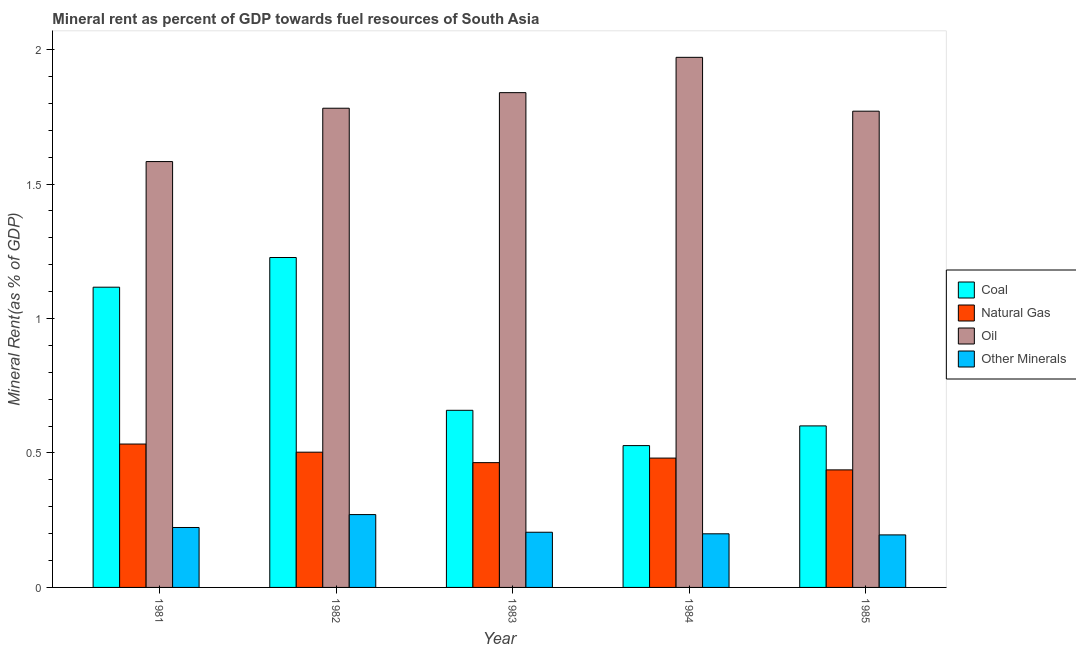How many groups of bars are there?
Provide a succinct answer. 5. Are the number of bars per tick equal to the number of legend labels?
Offer a terse response. Yes. How many bars are there on the 5th tick from the right?
Offer a very short reply. 4. In how many cases, is the number of bars for a given year not equal to the number of legend labels?
Make the answer very short. 0. What is the coal rent in 1984?
Provide a short and direct response. 0.53. Across all years, what is the maximum oil rent?
Keep it short and to the point. 1.97. Across all years, what is the minimum natural gas rent?
Provide a short and direct response. 0.44. In which year was the coal rent maximum?
Offer a terse response. 1982. In which year was the coal rent minimum?
Ensure brevity in your answer.  1984. What is the total  rent of other minerals in the graph?
Provide a succinct answer. 1.09. What is the difference between the natural gas rent in 1982 and that in 1983?
Offer a very short reply. 0.04. What is the difference between the  rent of other minerals in 1985 and the oil rent in 1983?
Keep it short and to the point. -0.01. What is the average coal rent per year?
Your answer should be very brief. 0.83. In the year 1985, what is the difference between the natural gas rent and  rent of other minerals?
Provide a succinct answer. 0. What is the ratio of the oil rent in 1983 to that in 1984?
Offer a terse response. 0.93. Is the natural gas rent in 1982 less than that in 1984?
Give a very brief answer. No. What is the difference between the highest and the second highest oil rent?
Ensure brevity in your answer.  0.13. What is the difference between the highest and the lowest coal rent?
Offer a very short reply. 0.7. Is the sum of the natural gas rent in 1983 and 1984 greater than the maximum coal rent across all years?
Make the answer very short. Yes. What does the 3rd bar from the left in 1982 represents?
Keep it short and to the point. Oil. What does the 2nd bar from the right in 1981 represents?
Make the answer very short. Oil. Is it the case that in every year, the sum of the coal rent and natural gas rent is greater than the oil rent?
Keep it short and to the point. No. What is the difference between two consecutive major ticks on the Y-axis?
Your answer should be very brief. 0.5. Are the values on the major ticks of Y-axis written in scientific E-notation?
Give a very brief answer. No. Does the graph contain grids?
Offer a very short reply. No. How are the legend labels stacked?
Provide a short and direct response. Vertical. What is the title of the graph?
Ensure brevity in your answer.  Mineral rent as percent of GDP towards fuel resources of South Asia. Does "Secondary" appear as one of the legend labels in the graph?
Your answer should be compact. No. What is the label or title of the Y-axis?
Your answer should be compact. Mineral Rent(as % of GDP). What is the Mineral Rent(as % of GDP) of Coal in 1981?
Offer a very short reply. 1.12. What is the Mineral Rent(as % of GDP) of Natural Gas in 1981?
Give a very brief answer. 0.53. What is the Mineral Rent(as % of GDP) of Oil in 1981?
Offer a very short reply. 1.58. What is the Mineral Rent(as % of GDP) in Other Minerals in 1981?
Your answer should be very brief. 0.22. What is the Mineral Rent(as % of GDP) in Coal in 1982?
Provide a succinct answer. 1.23. What is the Mineral Rent(as % of GDP) in Natural Gas in 1982?
Make the answer very short. 0.5. What is the Mineral Rent(as % of GDP) in Oil in 1982?
Offer a very short reply. 1.78. What is the Mineral Rent(as % of GDP) in Other Minerals in 1982?
Make the answer very short. 0.27. What is the Mineral Rent(as % of GDP) in Coal in 1983?
Ensure brevity in your answer.  0.66. What is the Mineral Rent(as % of GDP) in Natural Gas in 1983?
Your answer should be very brief. 0.46. What is the Mineral Rent(as % of GDP) in Oil in 1983?
Your answer should be compact. 1.84. What is the Mineral Rent(as % of GDP) of Other Minerals in 1983?
Keep it short and to the point. 0.21. What is the Mineral Rent(as % of GDP) in Coal in 1984?
Your answer should be very brief. 0.53. What is the Mineral Rent(as % of GDP) of Natural Gas in 1984?
Offer a very short reply. 0.48. What is the Mineral Rent(as % of GDP) in Oil in 1984?
Provide a short and direct response. 1.97. What is the Mineral Rent(as % of GDP) in Other Minerals in 1984?
Provide a succinct answer. 0.2. What is the Mineral Rent(as % of GDP) of Coal in 1985?
Your answer should be very brief. 0.6. What is the Mineral Rent(as % of GDP) of Natural Gas in 1985?
Your response must be concise. 0.44. What is the Mineral Rent(as % of GDP) of Oil in 1985?
Provide a short and direct response. 1.77. What is the Mineral Rent(as % of GDP) in Other Minerals in 1985?
Your answer should be very brief. 0.2. Across all years, what is the maximum Mineral Rent(as % of GDP) in Coal?
Ensure brevity in your answer.  1.23. Across all years, what is the maximum Mineral Rent(as % of GDP) of Natural Gas?
Provide a succinct answer. 0.53. Across all years, what is the maximum Mineral Rent(as % of GDP) in Oil?
Keep it short and to the point. 1.97. Across all years, what is the maximum Mineral Rent(as % of GDP) of Other Minerals?
Provide a short and direct response. 0.27. Across all years, what is the minimum Mineral Rent(as % of GDP) in Coal?
Ensure brevity in your answer.  0.53. Across all years, what is the minimum Mineral Rent(as % of GDP) in Natural Gas?
Give a very brief answer. 0.44. Across all years, what is the minimum Mineral Rent(as % of GDP) in Oil?
Your answer should be very brief. 1.58. Across all years, what is the minimum Mineral Rent(as % of GDP) in Other Minerals?
Make the answer very short. 0.2. What is the total Mineral Rent(as % of GDP) in Coal in the graph?
Your answer should be very brief. 4.13. What is the total Mineral Rent(as % of GDP) in Natural Gas in the graph?
Make the answer very short. 2.42. What is the total Mineral Rent(as % of GDP) of Oil in the graph?
Provide a short and direct response. 8.95. What is the total Mineral Rent(as % of GDP) in Other Minerals in the graph?
Give a very brief answer. 1.09. What is the difference between the Mineral Rent(as % of GDP) of Coal in 1981 and that in 1982?
Offer a terse response. -0.11. What is the difference between the Mineral Rent(as % of GDP) in Natural Gas in 1981 and that in 1982?
Give a very brief answer. 0.03. What is the difference between the Mineral Rent(as % of GDP) of Oil in 1981 and that in 1982?
Provide a succinct answer. -0.2. What is the difference between the Mineral Rent(as % of GDP) in Other Minerals in 1981 and that in 1982?
Offer a very short reply. -0.05. What is the difference between the Mineral Rent(as % of GDP) of Coal in 1981 and that in 1983?
Offer a very short reply. 0.46. What is the difference between the Mineral Rent(as % of GDP) of Natural Gas in 1981 and that in 1983?
Keep it short and to the point. 0.07. What is the difference between the Mineral Rent(as % of GDP) in Oil in 1981 and that in 1983?
Ensure brevity in your answer.  -0.26. What is the difference between the Mineral Rent(as % of GDP) in Other Minerals in 1981 and that in 1983?
Your answer should be very brief. 0.02. What is the difference between the Mineral Rent(as % of GDP) in Coal in 1981 and that in 1984?
Make the answer very short. 0.59. What is the difference between the Mineral Rent(as % of GDP) in Natural Gas in 1981 and that in 1984?
Offer a terse response. 0.05. What is the difference between the Mineral Rent(as % of GDP) of Oil in 1981 and that in 1984?
Provide a short and direct response. -0.39. What is the difference between the Mineral Rent(as % of GDP) of Other Minerals in 1981 and that in 1984?
Make the answer very short. 0.02. What is the difference between the Mineral Rent(as % of GDP) of Coal in 1981 and that in 1985?
Ensure brevity in your answer.  0.52. What is the difference between the Mineral Rent(as % of GDP) in Natural Gas in 1981 and that in 1985?
Offer a terse response. 0.1. What is the difference between the Mineral Rent(as % of GDP) of Oil in 1981 and that in 1985?
Give a very brief answer. -0.19. What is the difference between the Mineral Rent(as % of GDP) of Other Minerals in 1981 and that in 1985?
Offer a very short reply. 0.03. What is the difference between the Mineral Rent(as % of GDP) in Coal in 1982 and that in 1983?
Offer a terse response. 0.57. What is the difference between the Mineral Rent(as % of GDP) of Natural Gas in 1982 and that in 1983?
Offer a very short reply. 0.04. What is the difference between the Mineral Rent(as % of GDP) of Oil in 1982 and that in 1983?
Offer a terse response. -0.06. What is the difference between the Mineral Rent(as % of GDP) of Other Minerals in 1982 and that in 1983?
Make the answer very short. 0.07. What is the difference between the Mineral Rent(as % of GDP) in Coal in 1982 and that in 1984?
Your answer should be very brief. 0.7. What is the difference between the Mineral Rent(as % of GDP) in Natural Gas in 1982 and that in 1984?
Your answer should be compact. 0.02. What is the difference between the Mineral Rent(as % of GDP) of Oil in 1982 and that in 1984?
Provide a short and direct response. -0.19. What is the difference between the Mineral Rent(as % of GDP) in Other Minerals in 1982 and that in 1984?
Your answer should be very brief. 0.07. What is the difference between the Mineral Rent(as % of GDP) in Coal in 1982 and that in 1985?
Provide a short and direct response. 0.63. What is the difference between the Mineral Rent(as % of GDP) in Natural Gas in 1982 and that in 1985?
Keep it short and to the point. 0.07. What is the difference between the Mineral Rent(as % of GDP) in Oil in 1982 and that in 1985?
Offer a very short reply. 0.01. What is the difference between the Mineral Rent(as % of GDP) in Other Minerals in 1982 and that in 1985?
Your response must be concise. 0.08. What is the difference between the Mineral Rent(as % of GDP) of Coal in 1983 and that in 1984?
Make the answer very short. 0.13. What is the difference between the Mineral Rent(as % of GDP) of Natural Gas in 1983 and that in 1984?
Offer a terse response. -0.02. What is the difference between the Mineral Rent(as % of GDP) in Oil in 1983 and that in 1984?
Provide a succinct answer. -0.13. What is the difference between the Mineral Rent(as % of GDP) in Other Minerals in 1983 and that in 1984?
Provide a succinct answer. 0.01. What is the difference between the Mineral Rent(as % of GDP) in Coal in 1983 and that in 1985?
Provide a short and direct response. 0.06. What is the difference between the Mineral Rent(as % of GDP) of Natural Gas in 1983 and that in 1985?
Make the answer very short. 0.03. What is the difference between the Mineral Rent(as % of GDP) in Oil in 1983 and that in 1985?
Keep it short and to the point. 0.07. What is the difference between the Mineral Rent(as % of GDP) of Other Minerals in 1983 and that in 1985?
Offer a terse response. 0.01. What is the difference between the Mineral Rent(as % of GDP) of Coal in 1984 and that in 1985?
Provide a succinct answer. -0.07. What is the difference between the Mineral Rent(as % of GDP) in Natural Gas in 1984 and that in 1985?
Offer a very short reply. 0.04. What is the difference between the Mineral Rent(as % of GDP) of Oil in 1984 and that in 1985?
Your answer should be very brief. 0.2. What is the difference between the Mineral Rent(as % of GDP) of Other Minerals in 1984 and that in 1985?
Your answer should be very brief. 0. What is the difference between the Mineral Rent(as % of GDP) of Coal in 1981 and the Mineral Rent(as % of GDP) of Natural Gas in 1982?
Your response must be concise. 0.61. What is the difference between the Mineral Rent(as % of GDP) in Coal in 1981 and the Mineral Rent(as % of GDP) in Oil in 1982?
Give a very brief answer. -0.67. What is the difference between the Mineral Rent(as % of GDP) of Coal in 1981 and the Mineral Rent(as % of GDP) of Other Minerals in 1982?
Provide a short and direct response. 0.85. What is the difference between the Mineral Rent(as % of GDP) of Natural Gas in 1981 and the Mineral Rent(as % of GDP) of Oil in 1982?
Your answer should be compact. -1.25. What is the difference between the Mineral Rent(as % of GDP) in Natural Gas in 1981 and the Mineral Rent(as % of GDP) in Other Minerals in 1982?
Ensure brevity in your answer.  0.26. What is the difference between the Mineral Rent(as % of GDP) in Oil in 1981 and the Mineral Rent(as % of GDP) in Other Minerals in 1982?
Provide a short and direct response. 1.31. What is the difference between the Mineral Rent(as % of GDP) of Coal in 1981 and the Mineral Rent(as % of GDP) of Natural Gas in 1983?
Give a very brief answer. 0.65. What is the difference between the Mineral Rent(as % of GDP) in Coal in 1981 and the Mineral Rent(as % of GDP) in Oil in 1983?
Make the answer very short. -0.72. What is the difference between the Mineral Rent(as % of GDP) in Coal in 1981 and the Mineral Rent(as % of GDP) in Other Minerals in 1983?
Provide a short and direct response. 0.91. What is the difference between the Mineral Rent(as % of GDP) of Natural Gas in 1981 and the Mineral Rent(as % of GDP) of Oil in 1983?
Ensure brevity in your answer.  -1.31. What is the difference between the Mineral Rent(as % of GDP) in Natural Gas in 1981 and the Mineral Rent(as % of GDP) in Other Minerals in 1983?
Your response must be concise. 0.33. What is the difference between the Mineral Rent(as % of GDP) in Oil in 1981 and the Mineral Rent(as % of GDP) in Other Minerals in 1983?
Ensure brevity in your answer.  1.38. What is the difference between the Mineral Rent(as % of GDP) of Coal in 1981 and the Mineral Rent(as % of GDP) of Natural Gas in 1984?
Your answer should be very brief. 0.64. What is the difference between the Mineral Rent(as % of GDP) in Coal in 1981 and the Mineral Rent(as % of GDP) in Oil in 1984?
Give a very brief answer. -0.85. What is the difference between the Mineral Rent(as % of GDP) in Coal in 1981 and the Mineral Rent(as % of GDP) in Other Minerals in 1984?
Offer a very short reply. 0.92. What is the difference between the Mineral Rent(as % of GDP) in Natural Gas in 1981 and the Mineral Rent(as % of GDP) in Oil in 1984?
Your answer should be very brief. -1.44. What is the difference between the Mineral Rent(as % of GDP) in Natural Gas in 1981 and the Mineral Rent(as % of GDP) in Other Minerals in 1984?
Make the answer very short. 0.33. What is the difference between the Mineral Rent(as % of GDP) in Oil in 1981 and the Mineral Rent(as % of GDP) in Other Minerals in 1984?
Ensure brevity in your answer.  1.38. What is the difference between the Mineral Rent(as % of GDP) of Coal in 1981 and the Mineral Rent(as % of GDP) of Natural Gas in 1985?
Offer a very short reply. 0.68. What is the difference between the Mineral Rent(as % of GDP) of Coal in 1981 and the Mineral Rent(as % of GDP) of Oil in 1985?
Your answer should be compact. -0.65. What is the difference between the Mineral Rent(as % of GDP) of Coal in 1981 and the Mineral Rent(as % of GDP) of Other Minerals in 1985?
Make the answer very short. 0.92. What is the difference between the Mineral Rent(as % of GDP) in Natural Gas in 1981 and the Mineral Rent(as % of GDP) in Oil in 1985?
Keep it short and to the point. -1.24. What is the difference between the Mineral Rent(as % of GDP) in Natural Gas in 1981 and the Mineral Rent(as % of GDP) in Other Minerals in 1985?
Provide a short and direct response. 0.34. What is the difference between the Mineral Rent(as % of GDP) of Oil in 1981 and the Mineral Rent(as % of GDP) of Other Minerals in 1985?
Make the answer very short. 1.39. What is the difference between the Mineral Rent(as % of GDP) in Coal in 1982 and the Mineral Rent(as % of GDP) in Natural Gas in 1983?
Offer a very short reply. 0.76. What is the difference between the Mineral Rent(as % of GDP) of Coal in 1982 and the Mineral Rent(as % of GDP) of Oil in 1983?
Provide a short and direct response. -0.61. What is the difference between the Mineral Rent(as % of GDP) of Coal in 1982 and the Mineral Rent(as % of GDP) of Other Minerals in 1983?
Offer a terse response. 1.02. What is the difference between the Mineral Rent(as % of GDP) of Natural Gas in 1982 and the Mineral Rent(as % of GDP) of Oil in 1983?
Keep it short and to the point. -1.34. What is the difference between the Mineral Rent(as % of GDP) in Natural Gas in 1982 and the Mineral Rent(as % of GDP) in Other Minerals in 1983?
Provide a short and direct response. 0.3. What is the difference between the Mineral Rent(as % of GDP) of Oil in 1982 and the Mineral Rent(as % of GDP) of Other Minerals in 1983?
Give a very brief answer. 1.58. What is the difference between the Mineral Rent(as % of GDP) in Coal in 1982 and the Mineral Rent(as % of GDP) in Natural Gas in 1984?
Your answer should be very brief. 0.75. What is the difference between the Mineral Rent(as % of GDP) of Coal in 1982 and the Mineral Rent(as % of GDP) of Oil in 1984?
Your answer should be compact. -0.74. What is the difference between the Mineral Rent(as % of GDP) in Coal in 1982 and the Mineral Rent(as % of GDP) in Other Minerals in 1984?
Make the answer very short. 1.03. What is the difference between the Mineral Rent(as % of GDP) in Natural Gas in 1982 and the Mineral Rent(as % of GDP) in Oil in 1984?
Give a very brief answer. -1.47. What is the difference between the Mineral Rent(as % of GDP) in Natural Gas in 1982 and the Mineral Rent(as % of GDP) in Other Minerals in 1984?
Provide a short and direct response. 0.3. What is the difference between the Mineral Rent(as % of GDP) of Oil in 1982 and the Mineral Rent(as % of GDP) of Other Minerals in 1984?
Provide a short and direct response. 1.58. What is the difference between the Mineral Rent(as % of GDP) in Coal in 1982 and the Mineral Rent(as % of GDP) in Natural Gas in 1985?
Give a very brief answer. 0.79. What is the difference between the Mineral Rent(as % of GDP) in Coal in 1982 and the Mineral Rent(as % of GDP) in Oil in 1985?
Your answer should be compact. -0.54. What is the difference between the Mineral Rent(as % of GDP) of Coal in 1982 and the Mineral Rent(as % of GDP) of Other Minerals in 1985?
Offer a terse response. 1.03. What is the difference between the Mineral Rent(as % of GDP) of Natural Gas in 1982 and the Mineral Rent(as % of GDP) of Oil in 1985?
Your answer should be compact. -1.27. What is the difference between the Mineral Rent(as % of GDP) in Natural Gas in 1982 and the Mineral Rent(as % of GDP) in Other Minerals in 1985?
Offer a terse response. 0.31. What is the difference between the Mineral Rent(as % of GDP) in Oil in 1982 and the Mineral Rent(as % of GDP) in Other Minerals in 1985?
Provide a succinct answer. 1.59. What is the difference between the Mineral Rent(as % of GDP) in Coal in 1983 and the Mineral Rent(as % of GDP) in Natural Gas in 1984?
Your answer should be very brief. 0.18. What is the difference between the Mineral Rent(as % of GDP) in Coal in 1983 and the Mineral Rent(as % of GDP) in Oil in 1984?
Provide a short and direct response. -1.31. What is the difference between the Mineral Rent(as % of GDP) of Coal in 1983 and the Mineral Rent(as % of GDP) of Other Minerals in 1984?
Ensure brevity in your answer.  0.46. What is the difference between the Mineral Rent(as % of GDP) of Natural Gas in 1983 and the Mineral Rent(as % of GDP) of Oil in 1984?
Offer a terse response. -1.51. What is the difference between the Mineral Rent(as % of GDP) in Natural Gas in 1983 and the Mineral Rent(as % of GDP) in Other Minerals in 1984?
Offer a very short reply. 0.26. What is the difference between the Mineral Rent(as % of GDP) of Oil in 1983 and the Mineral Rent(as % of GDP) of Other Minerals in 1984?
Keep it short and to the point. 1.64. What is the difference between the Mineral Rent(as % of GDP) of Coal in 1983 and the Mineral Rent(as % of GDP) of Natural Gas in 1985?
Ensure brevity in your answer.  0.22. What is the difference between the Mineral Rent(as % of GDP) of Coal in 1983 and the Mineral Rent(as % of GDP) of Oil in 1985?
Your answer should be very brief. -1.11. What is the difference between the Mineral Rent(as % of GDP) of Coal in 1983 and the Mineral Rent(as % of GDP) of Other Minerals in 1985?
Your answer should be compact. 0.46. What is the difference between the Mineral Rent(as % of GDP) of Natural Gas in 1983 and the Mineral Rent(as % of GDP) of Oil in 1985?
Offer a terse response. -1.31. What is the difference between the Mineral Rent(as % of GDP) of Natural Gas in 1983 and the Mineral Rent(as % of GDP) of Other Minerals in 1985?
Give a very brief answer. 0.27. What is the difference between the Mineral Rent(as % of GDP) of Oil in 1983 and the Mineral Rent(as % of GDP) of Other Minerals in 1985?
Your response must be concise. 1.64. What is the difference between the Mineral Rent(as % of GDP) of Coal in 1984 and the Mineral Rent(as % of GDP) of Natural Gas in 1985?
Your answer should be very brief. 0.09. What is the difference between the Mineral Rent(as % of GDP) of Coal in 1984 and the Mineral Rent(as % of GDP) of Oil in 1985?
Offer a very short reply. -1.24. What is the difference between the Mineral Rent(as % of GDP) of Coal in 1984 and the Mineral Rent(as % of GDP) of Other Minerals in 1985?
Your answer should be very brief. 0.33. What is the difference between the Mineral Rent(as % of GDP) of Natural Gas in 1984 and the Mineral Rent(as % of GDP) of Oil in 1985?
Ensure brevity in your answer.  -1.29. What is the difference between the Mineral Rent(as % of GDP) in Natural Gas in 1984 and the Mineral Rent(as % of GDP) in Other Minerals in 1985?
Provide a short and direct response. 0.29. What is the difference between the Mineral Rent(as % of GDP) of Oil in 1984 and the Mineral Rent(as % of GDP) of Other Minerals in 1985?
Give a very brief answer. 1.78. What is the average Mineral Rent(as % of GDP) of Coal per year?
Provide a short and direct response. 0.83. What is the average Mineral Rent(as % of GDP) of Natural Gas per year?
Make the answer very short. 0.48. What is the average Mineral Rent(as % of GDP) in Oil per year?
Provide a short and direct response. 1.79. What is the average Mineral Rent(as % of GDP) of Other Minerals per year?
Offer a terse response. 0.22. In the year 1981, what is the difference between the Mineral Rent(as % of GDP) of Coal and Mineral Rent(as % of GDP) of Natural Gas?
Give a very brief answer. 0.58. In the year 1981, what is the difference between the Mineral Rent(as % of GDP) in Coal and Mineral Rent(as % of GDP) in Oil?
Make the answer very short. -0.47. In the year 1981, what is the difference between the Mineral Rent(as % of GDP) in Coal and Mineral Rent(as % of GDP) in Other Minerals?
Offer a very short reply. 0.89. In the year 1981, what is the difference between the Mineral Rent(as % of GDP) in Natural Gas and Mineral Rent(as % of GDP) in Oil?
Provide a succinct answer. -1.05. In the year 1981, what is the difference between the Mineral Rent(as % of GDP) in Natural Gas and Mineral Rent(as % of GDP) in Other Minerals?
Provide a short and direct response. 0.31. In the year 1981, what is the difference between the Mineral Rent(as % of GDP) in Oil and Mineral Rent(as % of GDP) in Other Minerals?
Keep it short and to the point. 1.36. In the year 1982, what is the difference between the Mineral Rent(as % of GDP) of Coal and Mineral Rent(as % of GDP) of Natural Gas?
Provide a succinct answer. 0.72. In the year 1982, what is the difference between the Mineral Rent(as % of GDP) in Coal and Mineral Rent(as % of GDP) in Oil?
Your answer should be very brief. -0.56. In the year 1982, what is the difference between the Mineral Rent(as % of GDP) in Coal and Mineral Rent(as % of GDP) in Other Minerals?
Your answer should be compact. 0.96. In the year 1982, what is the difference between the Mineral Rent(as % of GDP) of Natural Gas and Mineral Rent(as % of GDP) of Oil?
Keep it short and to the point. -1.28. In the year 1982, what is the difference between the Mineral Rent(as % of GDP) of Natural Gas and Mineral Rent(as % of GDP) of Other Minerals?
Your answer should be compact. 0.23. In the year 1982, what is the difference between the Mineral Rent(as % of GDP) in Oil and Mineral Rent(as % of GDP) in Other Minerals?
Your response must be concise. 1.51. In the year 1983, what is the difference between the Mineral Rent(as % of GDP) in Coal and Mineral Rent(as % of GDP) in Natural Gas?
Your answer should be compact. 0.19. In the year 1983, what is the difference between the Mineral Rent(as % of GDP) of Coal and Mineral Rent(as % of GDP) of Oil?
Provide a short and direct response. -1.18. In the year 1983, what is the difference between the Mineral Rent(as % of GDP) of Coal and Mineral Rent(as % of GDP) of Other Minerals?
Keep it short and to the point. 0.45. In the year 1983, what is the difference between the Mineral Rent(as % of GDP) in Natural Gas and Mineral Rent(as % of GDP) in Oil?
Offer a terse response. -1.38. In the year 1983, what is the difference between the Mineral Rent(as % of GDP) of Natural Gas and Mineral Rent(as % of GDP) of Other Minerals?
Offer a terse response. 0.26. In the year 1983, what is the difference between the Mineral Rent(as % of GDP) of Oil and Mineral Rent(as % of GDP) of Other Minerals?
Provide a succinct answer. 1.63. In the year 1984, what is the difference between the Mineral Rent(as % of GDP) in Coal and Mineral Rent(as % of GDP) in Natural Gas?
Offer a very short reply. 0.05. In the year 1984, what is the difference between the Mineral Rent(as % of GDP) in Coal and Mineral Rent(as % of GDP) in Oil?
Your response must be concise. -1.44. In the year 1984, what is the difference between the Mineral Rent(as % of GDP) in Coal and Mineral Rent(as % of GDP) in Other Minerals?
Your response must be concise. 0.33. In the year 1984, what is the difference between the Mineral Rent(as % of GDP) in Natural Gas and Mineral Rent(as % of GDP) in Oil?
Provide a succinct answer. -1.49. In the year 1984, what is the difference between the Mineral Rent(as % of GDP) in Natural Gas and Mineral Rent(as % of GDP) in Other Minerals?
Offer a terse response. 0.28. In the year 1984, what is the difference between the Mineral Rent(as % of GDP) of Oil and Mineral Rent(as % of GDP) of Other Minerals?
Give a very brief answer. 1.77. In the year 1985, what is the difference between the Mineral Rent(as % of GDP) in Coal and Mineral Rent(as % of GDP) in Natural Gas?
Your answer should be compact. 0.16. In the year 1985, what is the difference between the Mineral Rent(as % of GDP) of Coal and Mineral Rent(as % of GDP) of Oil?
Give a very brief answer. -1.17. In the year 1985, what is the difference between the Mineral Rent(as % of GDP) in Coal and Mineral Rent(as % of GDP) in Other Minerals?
Provide a succinct answer. 0.41. In the year 1985, what is the difference between the Mineral Rent(as % of GDP) of Natural Gas and Mineral Rent(as % of GDP) of Oil?
Offer a terse response. -1.33. In the year 1985, what is the difference between the Mineral Rent(as % of GDP) in Natural Gas and Mineral Rent(as % of GDP) in Other Minerals?
Keep it short and to the point. 0.24. In the year 1985, what is the difference between the Mineral Rent(as % of GDP) in Oil and Mineral Rent(as % of GDP) in Other Minerals?
Keep it short and to the point. 1.58. What is the ratio of the Mineral Rent(as % of GDP) in Coal in 1981 to that in 1982?
Your answer should be compact. 0.91. What is the ratio of the Mineral Rent(as % of GDP) of Natural Gas in 1981 to that in 1982?
Offer a terse response. 1.06. What is the ratio of the Mineral Rent(as % of GDP) of Oil in 1981 to that in 1982?
Provide a succinct answer. 0.89. What is the ratio of the Mineral Rent(as % of GDP) in Other Minerals in 1981 to that in 1982?
Offer a terse response. 0.82. What is the ratio of the Mineral Rent(as % of GDP) of Coal in 1981 to that in 1983?
Your answer should be very brief. 1.7. What is the ratio of the Mineral Rent(as % of GDP) in Natural Gas in 1981 to that in 1983?
Provide a succinct answer. 1.15. What is the ratio of the Mineral Rent(as % of GDP) in Oil in 1981 to that in 1983?
Your answer should be very brief. 0.86. What is the ratio of the Mineral Rent(as % of GDP) of Other Minerals in 1981 to that in 1983?
Offer a very short reply. 1.09. What is the ratio of the Mineral Rent(as % of GDP) in Coal in 1981 to that in 1984?
Offer a terse response. 2.12. What is the ratio of the Mineral Rent(as % of GDP) of Natural Gas in 1981 to that in 1984?
Keep it short and to the point. 1.11. What is the ratio of the Mineral Rent(as % of GDP) of Oil in 1981 to that in 1984?
Offer a terse response. 0.8. What is the ratio of the Mineral Rent(as % of GDP) in Other Minerals in 1981 to that in 1984?
Your answer should be compact. 1.12. What is the ratio of the Mineral Rent(as % of GDP) of Coal in 1981 to that in 1985?
Your answer should be very brief. 1.86. What is the ratio of the Mineral Rent(as % of GDP) in Natural Gas in 1981 to that in 1985?
Provide a succinct answer. 1.22. What is the ratio of the Mineral Rent(as % of GDP) in Oil in 1981 to that in 1985?
Offer a very short reply. 0.89. What is the ratio of the Mineral Rent(as % of GDP) in Other Minerals in 1981 to that in 1985?
Provide a short and direct response. 1.14. What is the ratio of the Mineral Rent(as % of GDP) of Coal in 1982 to that in 1983?
Keep it short and to the point. 1.86. What is the ratio of the Mineral Rent(as % of GDP) of Natural Gas in 1982 to that in 1983?
Give a very brief answer. 1.08. What is the ratio of the Mineral Rent(as % of GDP) in Oil in 1982 to that in 1983?
Make the answer very short. 0.97. What is the ratio of the Mineral Rent(as % of GDP) in Other Minerals in 1982 to that in 1983?
Your answer should be compact. 1.32. What is the ratio of the Mineral Rent(as % of GDP) of Coal in 1982 to that in 1984?
Keep it short and to the point. 2.33. What is the ratio of the Mineral Rent(as % of GDP) of Natural Gas in 1982 to that in 1984?
Offer a very short reply. 1.05. What is the ratio of the Mineral Rent(as % of GDP) of Oil in 1982 to that in 1984?
Provide a short and direct response. 0.9. What is the ratio of the Mineral Rent(as % of GDP) of Other Minerals in 1982 to that in 1984?
Offer a terse response. 1.36. What is the ratio of the Mineral Rent(as % of GDP) in Coal in 1982 to that in 1985?
Provide a short and direct response. 2.04. What is the ratio of the Mineral Rent(as % of GDP) in Natural Gas in 1982 to that in 1985?
Provide a succinct answer. 1.15. What is the ratio of the Mineral Rent(as % of GDP) of Other Minerals in 1982 to that in 1985?
Offer a very short reply. 1.39. What is the ratio of the Mineral Rent(as % of GDP) in Coal in 1983 to that in 1984?
Your answer should be very brief. 1.25. What is the ratio of the Mineral Rent(as % of GDP) in Natural Gas in 1983 to that in 1984?
Your answer should be compact. 0.96. What is the ratio of the Mineral Rent(as % of GDP) of Oil in 1983 to that in 1984?
Provide a succinct answer. 0.93. What is the ratio of the Mineral Rent(as % of GDP) in Other Minerals in 1983 to that in 1984?
Your answer should be compact. 1.03. What is the ratio of the Mineral Rent(as % of GDP) in Coal in 1983 to that in 1985?
Your response must be concise. 1.1. What is the ratio of the Mineral Rent(as % of GDP) in Natural Gas in 1983 to that in 1985?
Offer a terse response. 1.06. What is the ratio of the Mineral Rent(as % of GDP) of Oil in 1983 to that in 1985?
Your response must be concise. 1.04. What is the ratio of the Mineral Rent(as % of GDP) in Other Minerals in 1983 to that in 1985?
Provide a succinct answer. 1.05. What is the ratio of the Mineral Rent(as % of GDP) of Coal in 1984 to that in 1985?
Keep it short and to the point. 0.88. What is the ratio of the Mineral Rent(as % of GDP) of Natural Gas in 1984 to that in 1985?
Provide a succinct answer. 1.1. What is the ratio of the Mineral Rent(as % of GDP) in Oil in 1984 to that in 1985?
Give a very brief answer. 1.11. What is the ratio of the Mineral Rent(as % of GDP) of Other Minerals in 1984 to that in 1985?
Your answer should be very brief. 1.02. What is the difference between the highest and the second highest Mineral Rent(as % of GDP) in Coal?
Your response must be concise. 0.11. What is the difference between the highest and the second highest Mineral Rent(as % of GDP) of Natural Gas?
Your answer should be very brief. 0.03. What is the difference between the highest and the second highest Mineral Rent(as % of GDP) of Oil?
Offer a very short reply. 0.13. What is the difference between the highest and the second highest Mineral Rent(as % of GDP) of Other Minerals?
Your answer should be very brief. 0.05. What is the difference between the highest and the lowest Mineral Rent(as % of GDP) in Coal?
Provide a succinct answer. 0.7. What is the difference between the highest and the lowest Mineral Rent(as % of GDP) of Natural Gas?
Provide a short and direct response. 0.1. What is the difference between the highest and the lowest Mineral Rent(as % of GDP) of Oil?
Your answer should be very brief. 0.39. What is the difference between the highest and the lowest Mineral Rent(as % of GDP) of Other Minerals?
Your answer should be very brief. 0.08. 